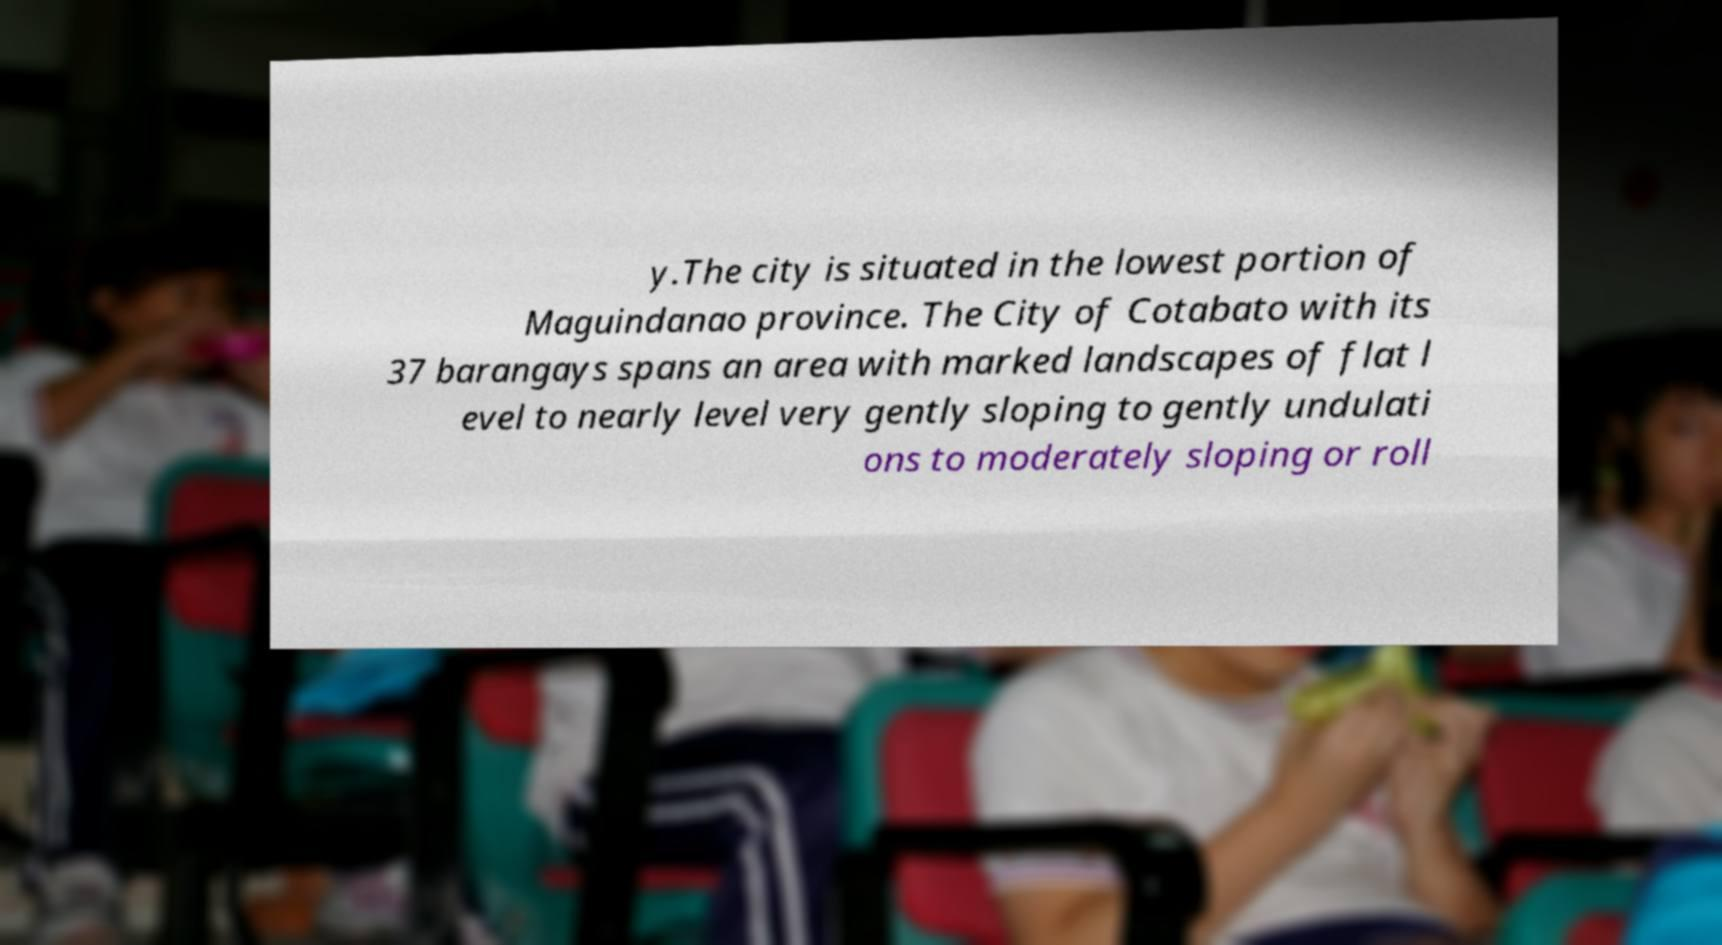There's text embedded in this image that I need extracted. Can you transcribe it verbatim? y.The city is situated in the lowest portion of Maguindanao province. The City of Cotabato with its 37 barangays spans an area with marked landscapes of flat l evel to nearly level very gently sloping to gently undulati ons to moderately sloping or roll 